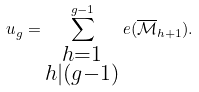<formula> <loc_0><loc_0><loc_500><loc_500>u _ { g } = \sum _ { \substack { h = 1 \\ h | ( g - 1 ) } } ^ { g - 1 } e ( { \overline { \mathcal { M } } } _ { h + 1 } ) .</formula> 